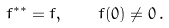Convert formula to latex. <formula><loc_0><loc_0><loc_500><loc_500>f ^ { * * } = f , \quad f ( 0 ) \neq 0 \, .</formula> 